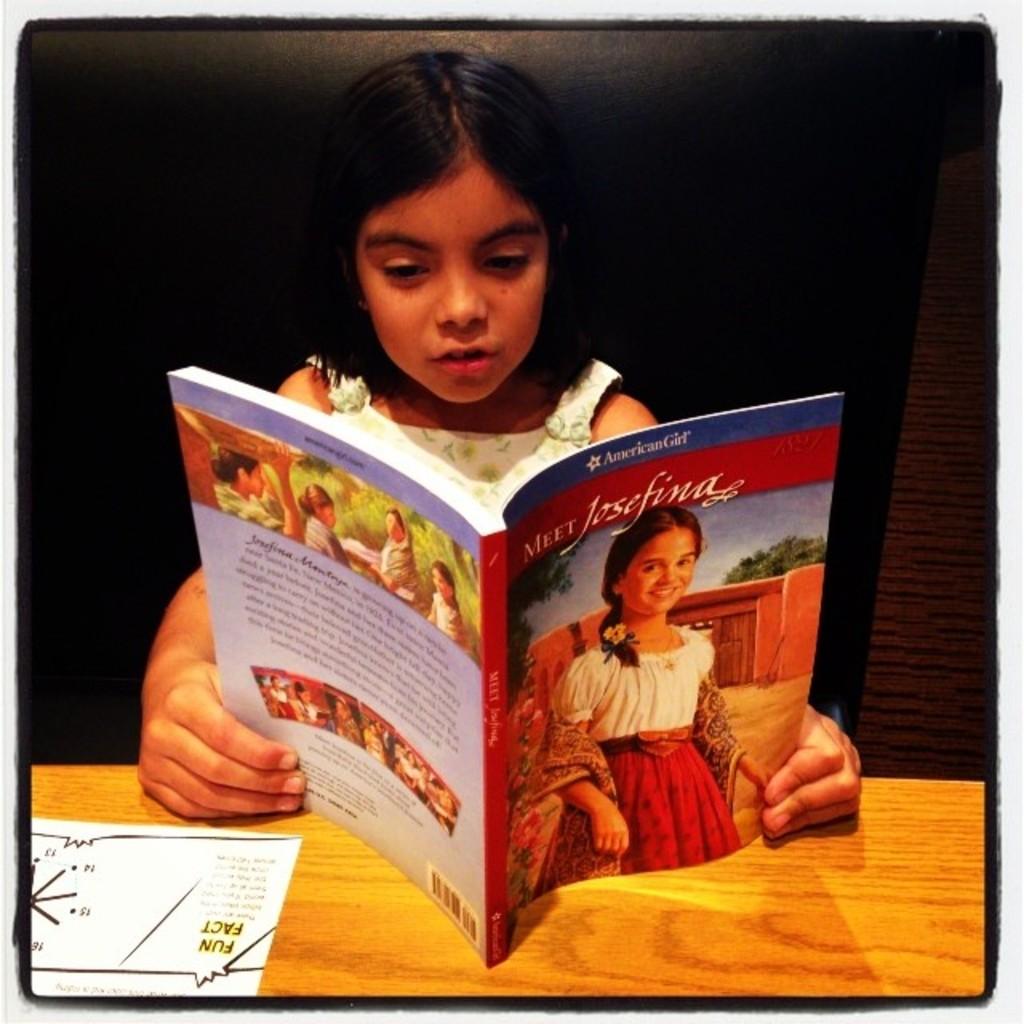What brand is this based on?
Make the answer very short. American girl. 